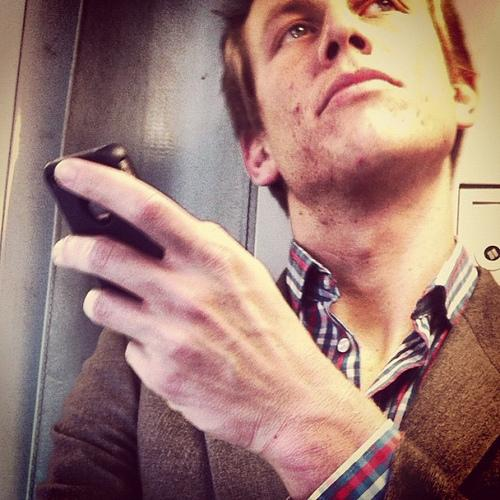How many objects can be seen in the image and can you provide a brief overview of them? There are several objects including a man, cellphone, checkered shirt, wool sportscoat, and the man's various fingers interacting with the phone. Evaluate the image subject's style in terms of clothing and accessories. The young man has a casual yet fashionable style, wearing a colorful checkered button-down shirt with white buttons, and a brown wool sportscoat. What are some key features of the man's face in this image? The man has blue eyes, brown hair, and visible nose and nostrils. How would you sum up the emotions portrayed in the image? The image depicts a thoughtful or introspective young man holding a cellphone. Can you provide a brief summary of the image content, focusing on the person and their attire? A young man with blue eyes and brown hair is holding a black cellphone, wearing a checkered button-down shirt, a brown wool sportscoat, and has a brown freckle on his wrist. Identify the different clothing items on the man and describe their colors and patterns. The man is wearing a red, white, and blue checkered shirt with white buttons, and a brown wool sportscoat. Describe the position of the man's fingers in relation to the cellphone. The man's index, middle, and pinky fingers are touching or interacting with the cellphone. What kind of phone is the man holding and what is he doing? The man is holding a black cellphone and appears to be thinking or looking up. What does the wrist of the man look like? The man's wrist has a brown freckle and is visible underneath his clothing items. What is the main interaction between the objects in the image? The main interaction is the man holding the black cellphone with his fingers, while wearing a checkered shirt and a brown sportscoat. Explain the main activity happening in the image. A young man holding and looking at his black cellphone while thinking Provide a styled image caption that describes the scene. A pensive young man with blue eyes and brown hair wearing a brown wool sportscoat and checkered plaid shirt while holding a black cellphone. Describe a distinctive feature on the man's wrist in the image. A brown freckle List the colors found in the man's checkered shirt. Red, white, and blue Identify a unique facial feature of the man in the plaid shirt. Blue eyes and brown hair Identify the type of the small objects on the man's plaid shirt. White buttons Analyze the image and describe the scene's overall theme. A young man wearing a checkered shirt and a brown sportscoat is holding and looking at a black cellphone, lost in thought. Notice the colorful umbrella behind the man with the cellphone No, it's not mentioned in the image. Check the image for text and provide the text found. No text found Which of the following describes the man's shirt? A) Plaid with white buttons, B) Striped with black buttons, C) Polka dots with silver buttons. A) Plaid with white buttons What is the man's hair color in the image? Brown Describe the color and pattern of the man's shirt. Red, white, and blue checkered plaid What's the prominent accessory held by the man in the image? Black cellphone Describe the coat the man in the image is wearing. Brown wool sportscoat What does the man's finger point to?  The phone's screen or nothing in particular What is the man holding in the image? A black cellphone Write a creative caption about the image. A contemplative gentleman donning a wool sportscoat and colorful checkered shirt while examining his trusty black cellphone with blue eyes. What color are the man's eyes? Blue Analyze the interaction between the man and the object he is holding. Man holding and looking at the black cellphone Determine what the man's fingers are doing in the image. Holding the black cellphone and having a relaxed grip 